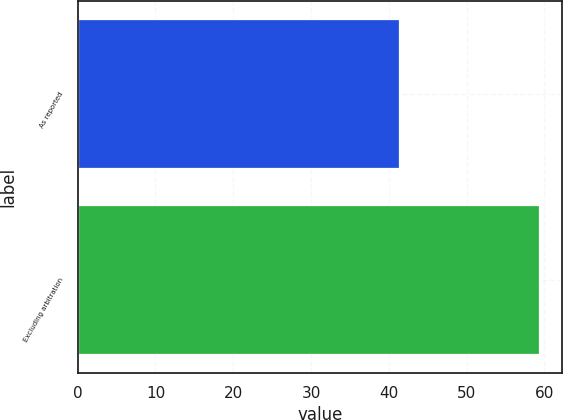Convert chart to OTSL. <chart><loc_0><loc_0><loc_500><loc_500><bar_chart><fcel>As reported<fcel>Excluding arbitration<nl><fcel>41.3<fcel>59.3<nl></chart> 